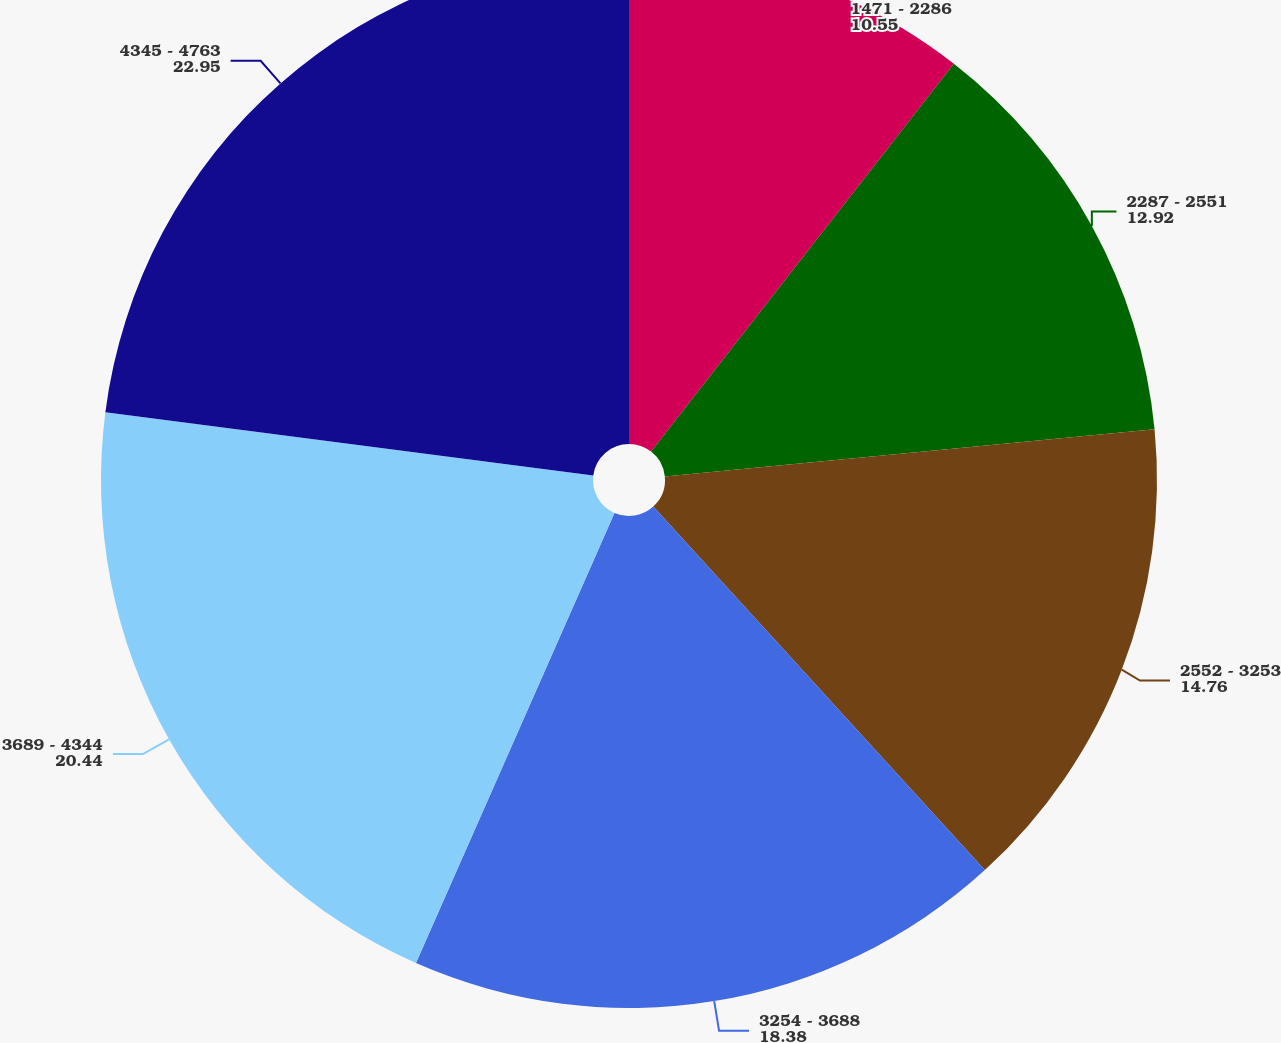Convert chart to OTSL. <chart><loc_0><loc_0><loc_500><loc_500><pie_chart><fcel>1471 - 2286<fcel>2287 - 2551<fcel>2552 - 3253<fcel>3254 - 3688<fcel>3689 - 4344<fcel>4345 - 4763<nl><fcel>10.55%<fcel>12.92%<fcel>14.76%<fcel>18.38%<fcel>20.44%<fcel>22.95%<nl></chart> 